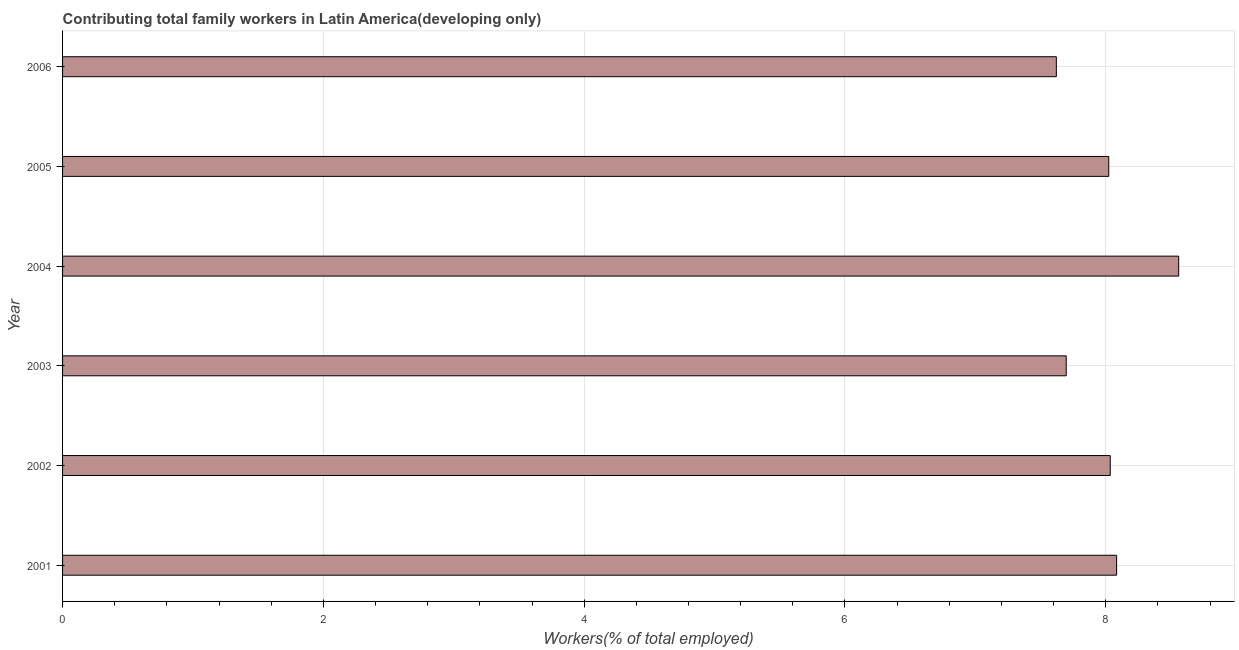Does the graph contain grids?
Give a very brief answer. Yes. What is the title of the graph?
Make the answer very short. Contributing total family workers in Latin America(developing only). What is the label or title of the X-axis?
Provide a short and direct response. Workers(% of total employed). What is the contributing family workers in 2003?
Make the answer very short. 7.7. Across all years, what is the maximum contributing family workers?
Your answer should be very brief. 8.56. Across all years, what is the minimum contributing family workers?
Offer a very short reply. 7.62. What is the sum of the contributing family workers?
Give a very brief answer. 48.02. What is the difference between the contributing family workers in 2003 and 2006?
Your answer should be very brief. 0.08. What is the average contributing family workers per year?
Provide a short and direct response. 8. What is the median contributing family workers?
Your answer should be compact. 8.03. What is the ratio of the contributing family workers in 2003 to that in 2006?
Provide a succinct answer. 1.01. Is the contributing family workers in 2001 less than that in 2002?
Offer a very short reply. No. Is the difference between the contributing family workers in 2002 and 2005 greater than the difference between any two years?
Your response must be concise. No. What is the difference between the highest and the second highest contributing family workers?
Ensure brevity in your answer.  0.48. Is the sum of the contributing family workers in 2002 and 2004 greater than the maximum contributing family workers across all years?
Offer a very short reply. Yes. What is the difference between the highest and the lowest contributing family workers?
Your answer should be compact. 0.94. In how many years, is the contributing family workers greater than the average contributing family workers taken over all years?
Give a very brief answer. 4. What is the difference between two consecutive major ticks on the X-axis?
Your answer should be compact. 2. What is the Workers(% of total employed) in 2001?
Provide a short and direct response. 8.08. What is the Workers(% of total employed) of 2002?
Ensure brevity in your answer.  8.03. What is the Workers(% of total employed) in 2003?
Provide a succinct answer. 7.7. What is the Workers(% of total employed) in 2004?
Offer a very short reply. 8.56. What is the Workers(% of total employed) of 2005?
Your response must be concise. 8.02. What is the Workers(% of total employed) of 2006?
Offer a terse response. 7.62. What is the difference between the Workers(% of total employed) in 2001 and 2002?
Provide a short and direct response. 0.05. What is the difference between the Workers(% of total employed) in 2001 and 2003?
Your answer should be very brief. 0.39. What is the difference between the Workers(% of total employed) in 2001 and 2004?
Give a very brief answer. -0.48. What is the difference between the Workers(% of total employed) in 2001 and 2005?
Your answer should be very brief. 0.06. What is the difference between the Workers(% of total employed) in 2001 and 2006?
Make the answer very short. 0.46. What is the difference between the Workers(% of total employed) in 2002 and 2003?
Your response must be concise. 0.34. What is the difference between the Workers(% of total employed) in 2002 and 2004?
Make the answer very short. -0.52. What is the difference between the Workers(% of total employed) in 2002 and 2005?
Provide a short and direct response. 0.01. What is the difference between the Workers(% of total employed) in 2002 and 2006?
Make the answer very short. 0.41. What is the difference between the Workers(% of total employed) in 2003 and 2004?
Provide a succinct answer. -0.86. What is the difference between the Workers(% of total employed) in 2003 and 2005?
Your answer should be very brief. -0.33. What is the difference between the Workers(% of total employed) in 2003 and 2006?
Give a very brief answer. 0.08. What is the difference between the Workers(% of total employed) in 2004 and 2005?
Ensure brevity in your answer.  0.54. What is the difference between the Workers(% of total employed) in 2004 and 2006?
Your answer should be compact. 0.94. What is the difference between the Workers(% of total employed) in 2005 and 2006?
Provide a short and direct response. 0.4. What is the ratio of the Workers(% of total employed) in 2001 to that in 2003?
Your response must be concise. 1.05. What is the ratio of the Workers(% of total employed) in 2001 to that in 2004?
Provide a short and direct response. 0.94. What is the ratio of the Workers(% of total employed) in 2001 to that in 2005?
Ensure brevity in your answer.  1.01. What is the ratio of the Workers(% of total employed) in 2001 to that in 2006?
Your answer should be compact. 1.06. What is the ratio of the Workers(% of total employed) in 2002 to that in 2003?
Your response must be concise. 1.04. What is the ratio of the Workers(% of total employed) in 2002 to that in 2004?
Ensure brevity in your answer.  0.94. What is the ratio of the Workers(% of total employed) in 2002 to that in 2005?
Offer a very short reply. 1. What is the ratio of the Workers(% of total employed) in 2002 to that in 2006?
Your answer should be compact. 1.05. What is the ratio of the Workers(% of total employed) in 2003 to that in 2004?
Your answer should be very brief. 0.9. What is the ratio of the Workers(% of total employed) in 2004 to that in 2005?
Provide a succinct answer. 1.07. What is the ratio of the Workers(% of total employed) in 2004 to that in 2006?
Offer a terse response. 1.12. What is the ratio of the Workers(% of total employed) in 2005 to that in 2006?
Make the answer very short. 1.05. 